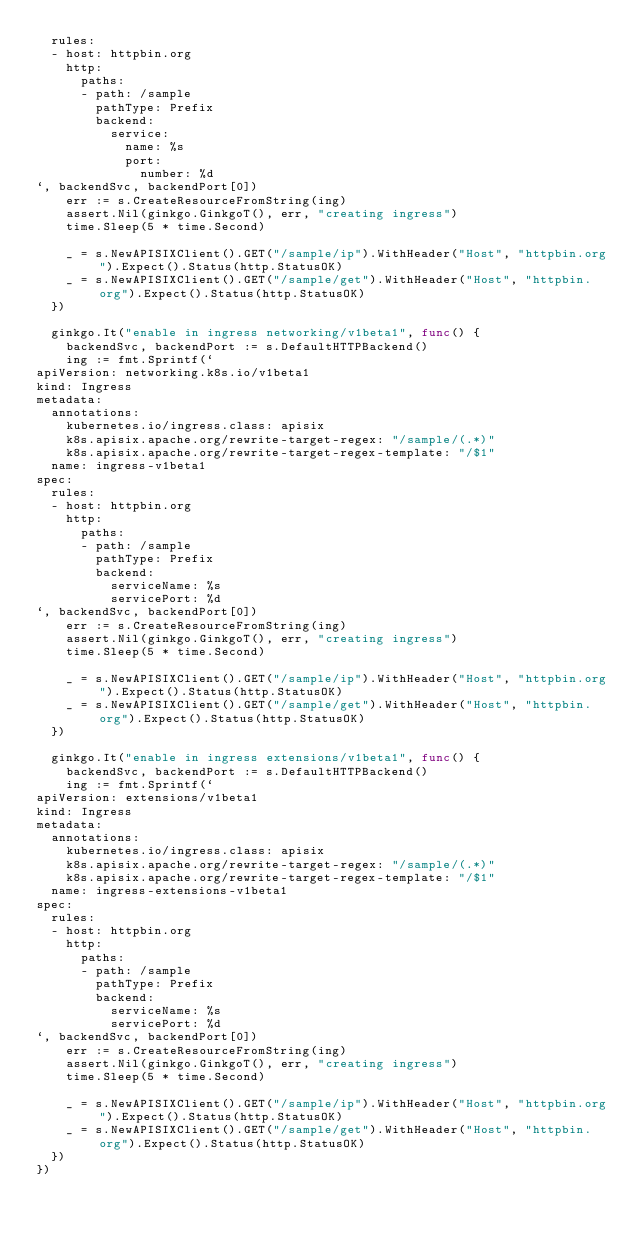Convert code to text. <code><loc_0><loc_0><loc_500><loc_500><_Go_>  rules:
  - host: httpbin.org
    http:
      paths:
      - path: /sample
        pathType: Prefix
        backend:
          service:
            name: %s
            port:
              number: %d
`, backendSvc, backendPort[0])
		err := s.CreateResourceFromString(ing)
		assert.Nil(ginkgo.GinkgoT(), err, "creating ingress")
		time.Sleep(5 * time.Second)

		_ = s.NewAPISIXClient().GET("/sample/ip").WithHeader("Host", "httpbin.org").Expect().Status(http.StatusOK)
		_ = s.NewAPISIXClient().GET("/sample/get").WithHeader("Host", "httpbin.org").Expect().Status(http.StatusOK)
	})

	ginkgo.It("enable in ingress networking/v1beta1", func() {
		backendSvc, backendPort := s.DefaultHTTPBackend()
		ing := fmt.Sprintf(`
apiVersion: networking.k8s.io/v1beta1
kind: Ingress
metadata:
  annotations:
    kubernetes.io/ingress.class: apisix
    k8s.apisix.apache.org/rewrite-target-regex: "/sample/(.*)"
    k8s.apisix.apache.org/rewrite-target-regex-template: "/$1"
  name: ingress-v1beta1
spec:
  rules:
  - host: httpbin.org
    http:
      paths:
      - path: /sample
        pathType: Prefix
        backend:
          serviceName: %s
          servicePort: %d
`, backendSvc, backendPort[0])
		err := s.CreateResourceFromString(ing)
		assert.Nil(ginkgo.GinkgoT(), err, "creating ingress")
		time.Sleep(5 * time.Second)

		_ = s.NewAPISIXClient().GET("/sample/ip").WithHeader("Host", "httpbin.org").Expect().Status(http.StatusOK)
		_ = s.NewAPISIXClient().GET("/sample/get").WithHeader("Host", "httpbin.org").Expect().Status(http.StatusOK)
	})

	ginkgo.It("enable in ingress extensions/v1beta1", func() {
		backendSvc, backendPort := s.DefaultHTTPBackend()
		ing := fmt.Sprintf(`
apiVersion: extensions/v1beta1
kind: Ingress
metadata:
  annotations:
    kubernetes.io/ingress.class: apisix
    k8s.apisix.apache.org/rewrite-target-regex: "/sample/(.*)"
    k8s.apisix.apache.org/rewrite-target-regex-template: "/$1"
  name: ingress-extensions-v1beta1
spec:
  rules:
  - host: httpbin.org
    http:
      paths:
      - path: /sample
        pathType: Prefix
        backend:
          serviceName: %s
          servicePort: %d
`, backendSvc, backendPort[0])
		err := s.CreateResourceFromString(ing)
		assert.Nil(ginkgo.GinkgoT(), err, "creating ingress")
		time.Sleep(5 * time.Second)

		_ = s.NewAPISIXClient().GET("/sample/ip").WithHeader("Host", "httpbin.org").Expect().Status(http.StatusOK)
		_ = s.NewAPISIXClient().GET("/sample/get").WithHeader("Host", "httpbin.org").Expect().Status(http.StatusOK)
	})
})
</code> 